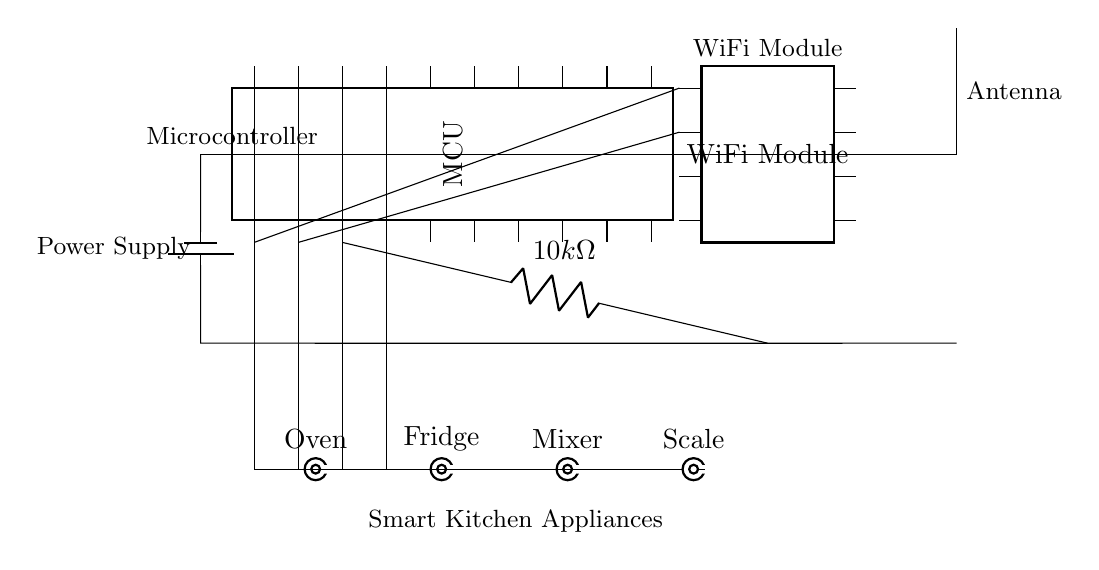What is the main component of this circuit? The main component is the microcontroller, which coordinates communication among the appliances and the WiFi module.
Answer: microcontroller How many pins does the WiFi module have? The WiFi module has 8 pins, as indicated in the circuit diagram.
Answer: 8 pins What is the resistance value shown in the circuit? The circuit includes a resistor with a value of 10k ohms, which is used to control the current flow.
Answer: 10k ohm Which appliances are connected to the microcontroller? The microcontroller is connected to four appliances: Oven, Fridge, Mixer, and Scale, which are represented in the circuit.
Answer: Oven, Fridge, Mixer, Scale What type of communication does this circuit utilize? The circuit utilizes wireless communication through a WiFi module, allowing synchronization of kitchen appliances.
Answer: wireless communication How is power supplied to the circuit? Power is supplied through a battery connected in parallel, providing voltage to the circuit components including the microcontroller and WiFi module.
Answer: battery What is the purpose of the antenna in this circuit? The antenna is designed to facilitate wireless signals, allowing the microcontroller to communicate with WiFi and manage smart appliances.
Answer: facilitate communication 